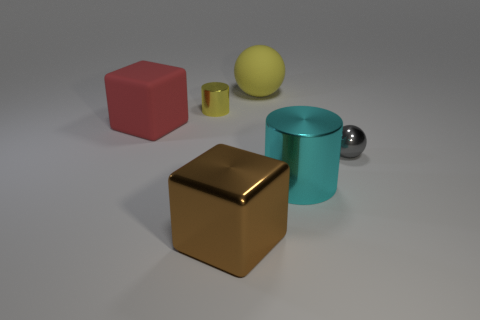Add 1 large purple matte cubes. How many objects exist? 7 Subtract all cylinders. How many objects are left? 4 Subtract 0 brown cylinders. How many objects are left? 6 Subtract all red shiny cubes. Subtract all tiny objects. How many objects are left? 4 Add 3 large red objects. How many large red objects are left? 4 Add 4 yellow cylinders. How many yellow cylinders exist? 5 